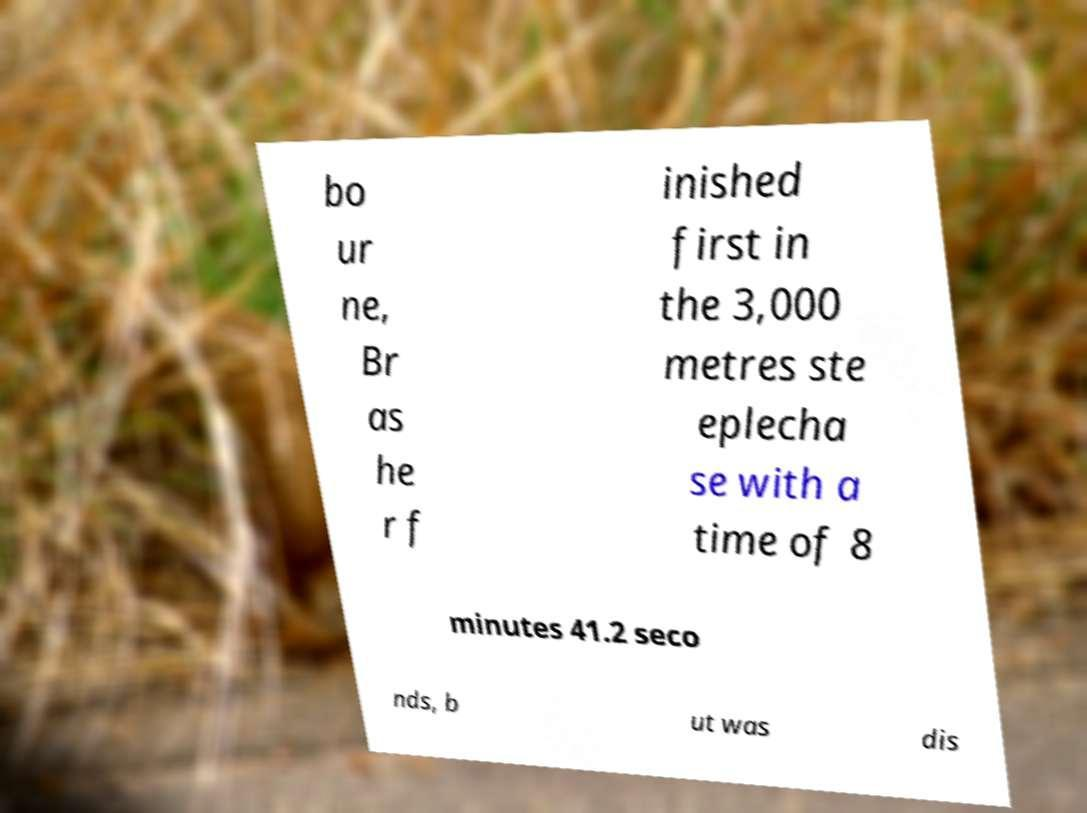Can you accurately transcribe the text from the provided image for me? bo ur ne, Br as he r f inished first in the 3,000 metres ste eplecha se with a time of 8 minutes 41.2 seco nds, b ut was dis 